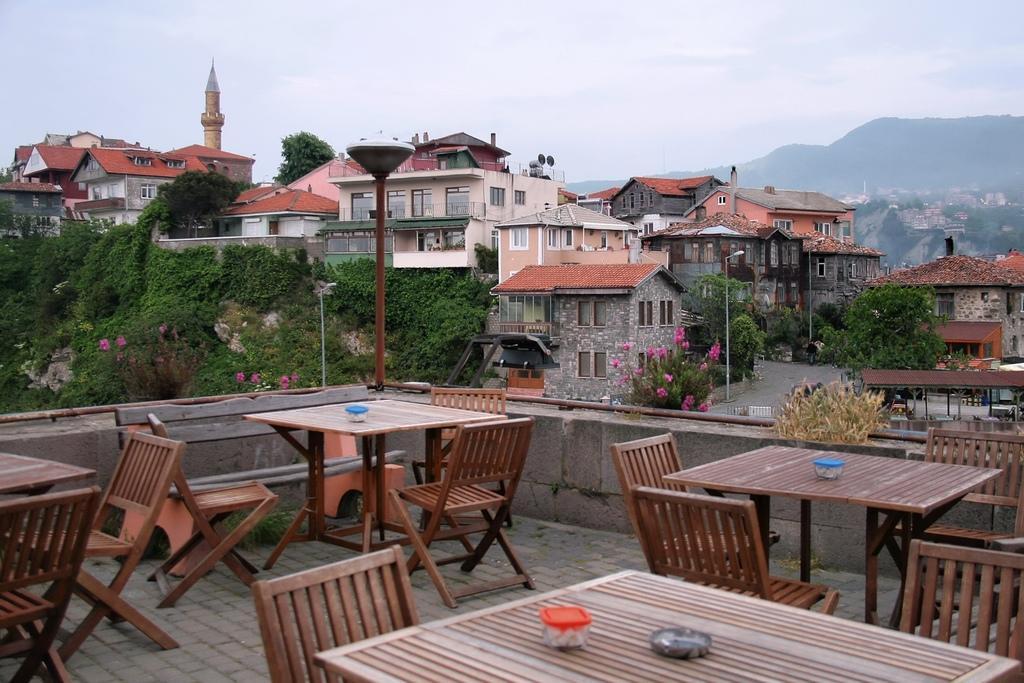How would you summarize this image in a sentence or two? In this image I can see the tables and chairs. On the tables I can see the boxes. To the side I can see the pole. In the background I can see the pink color flowers to the plants and there are many trees. In the background I can see the houses with windows, mountains and the sky. 